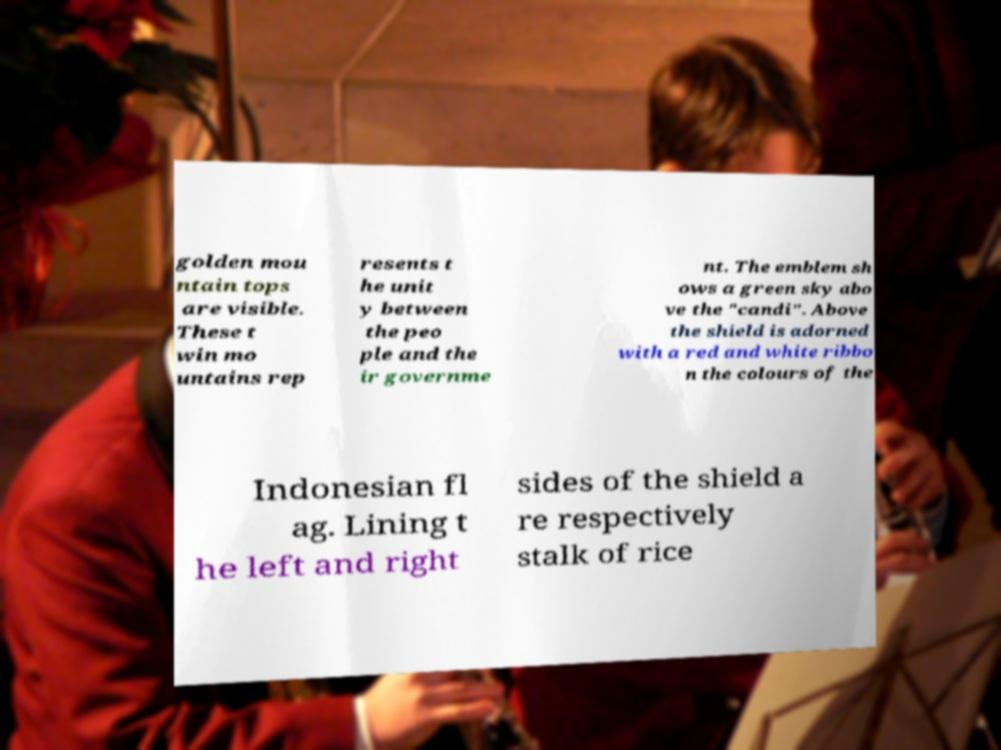What messages or text are displayed in this image? I need them in a readable, typed format. golden mou ntain tops are visible. These t win mo untains rep resents t he unit y between the peo ple and the ir governme nt. The emblem sh ows a green sky abo ve the "candi". Above the shield is adorned with a red and white ribbo n the colours of the Indonesian fl ag. Lining t he left and right sides of the shield a re respectively stalk of rice 